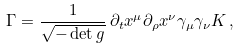Convert formula to latex. <formula><loc_0><loc_0><loc_500><loc_500>\Gamma = \frac { 1 } { \sqrt { - \det g } } \, \partial _ { t } x ^ { \mu } \partial _ { \rho } x ^ { \nu } \gamma _ { \mu } \gamma _ { \nu } K \, ,</formula> 